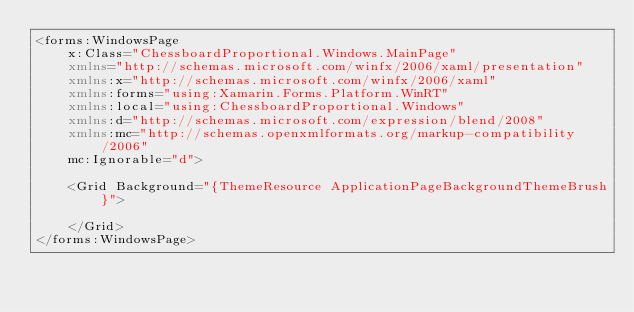Convert code to text. <code><loc_0><loc_0><loc_500><loc_500><_XML_><forms:WindowsPage
    x:Class="ChessboardProportional.Windows.MainPage"
    xmlns="http://schemas.microsoft.com/winfx/2006/xaml/presentation"
    xmlns:x="http://schemas.microsoft.com/winfx/2006/xaml"
    xmlns:forms="using:Xamarin.Forms.Platform.WinRT"
    xmlns:local="using:ChessboardProportional.Windows"
    xmlns:d="http://schemas.microsoft.com/expression/blend/2008"
    xmlns:mc="http://schemas.openxmlformats.org/markup-compatibility/2006"
    mc:Ignorable="d">

    <Grid Background="{ThemeResource ApplicationPageBackgroundThemeBrush}">

    </Grid>
</forms:WindowsPage>
</code> 